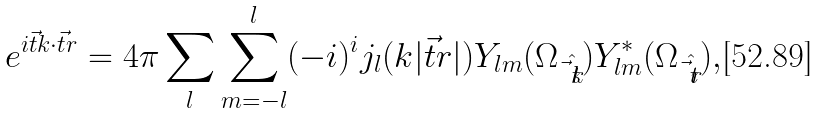<formula> <loc_0><loc_0><loc_500><loc_500>e ^ { i \vec { t } { k } \cdot \vec { t } { r } } = 4 \pi \sum _ { l } \sum ^ { l } _ { m = - l } ( - i ) ^ { i } j _ { l } ( k | \vec { t } { r } | ) Y _ { l m } ( \Omega _ { \hat { \vec { t } { k } } } ) Y ^ { * } _ { l m } ( \Omega _ { \hat { \vec { t } { r } } } ) ,</formula> 